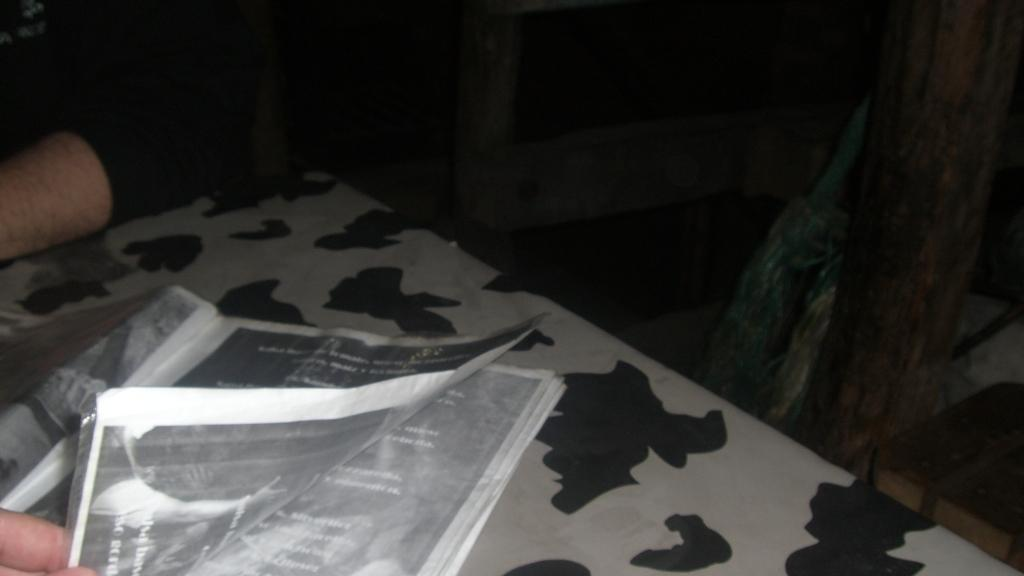What objects are on the table in the image? There are papers on the table in the image. What is the human hand doing in the image? A human hand is holding papers in the image. Can you describe the other human visible in the image? There is another human visible in the image. How would you describe the lighting conditions in the image? The image was taken in a dark environment. What type of ornament is hanging from the ceiling in the image? There is no ornament hanging from the ceiling in the image. How many brothers are visible in the image? The image does not show any brothers; it only shows a human hand holding papers and another human. 